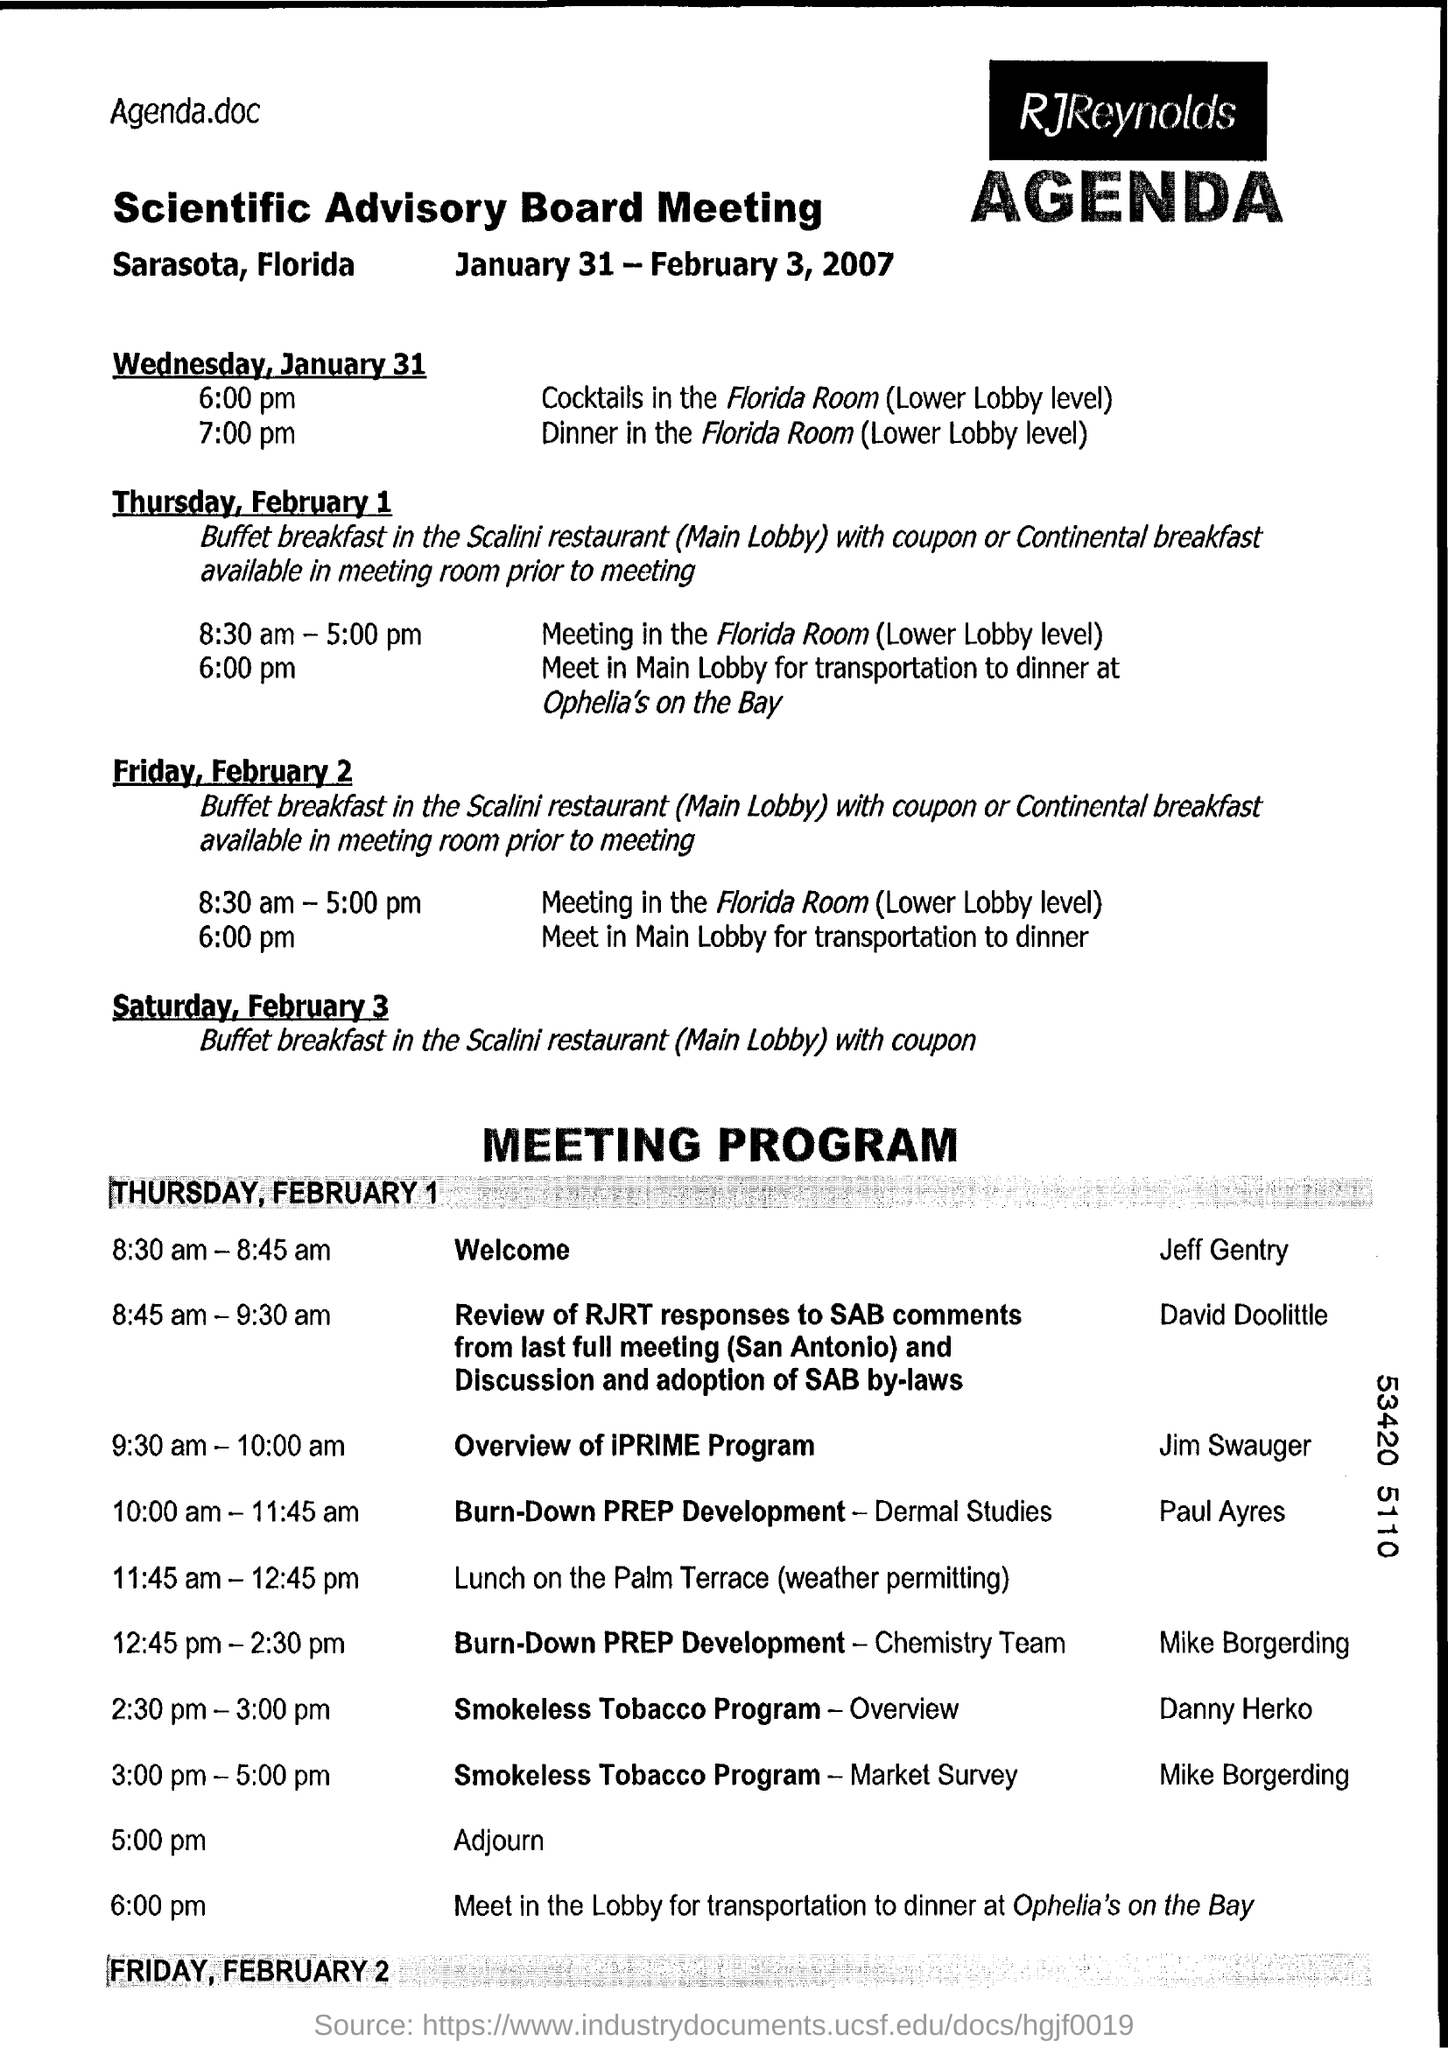Indicate a few pertinent items in this graphic. The meeting is located in Sarasota, Florida. The meeting is scheduled to begin on Wednesday, January 31. This is a scientific advisory board meeting. The Scientific Advisory Board meeting is scheduled to take place from January 31 to February 3, 2007. 